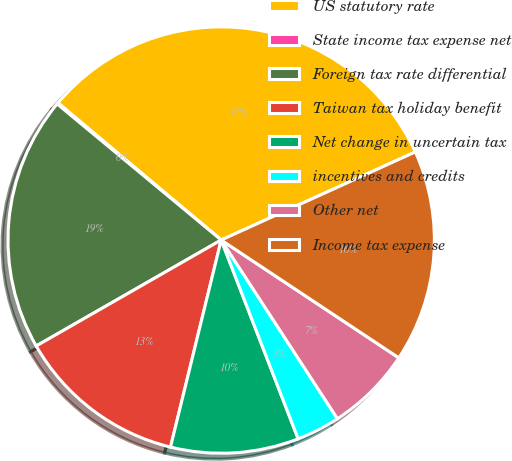Convert chart to OTSL. <chart><loc_0><loc_0><loc_500><loc_500><pie_chart><fcel>US statutory rate<fcel>State income tax expense net<fcel>Foreign tax rate differential<fcel>Taiwan tax holiday benefit<fcel>Net change in uncertain tax<fcel>incentives and credits<fcel>Other net<fcel>Income tax expense<nl><fcel>32.1%<fcel>0.1%<fcel>19.3%<fcel>12.9%<fcel>9.7%<fcel>3.3%<fcel>6.5%<fcel>16.1%<nl></chart> 